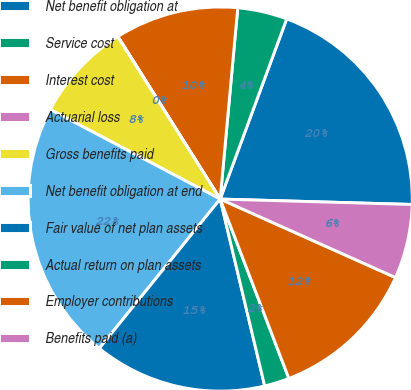Convert chart to OTSL. <chart><loc_0><loc_0><loc_500><loc_500><pie_chart><fcel>Net benefit obligation at<fcel>Service cost<fcel>Interest cost<fcel>Actuarial loss<fcel>Gross benefits paid<fcel>Net benefit obligation at end<fcel>Fair value of net plan assets<fcel>Actual return on plan assets<fcel>Employer contributions<fcel>Benefits paid (a)<nl><fcel>19.82%<fcel>4.17%<fcel>10.4%<fcel>0.02%<fcel>8.32%<fcel>21.89%<fcel>14.55%<fcel>2.1%<fcel>12.48%<fcel>6.25%<nl></chart> 